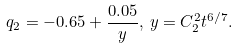<formula> <loc_0><loc_0><loc_500><loc_500>q _ { 2 } = - 0 . 6 5 + \frac { 0 . 0 5 } { y } , \, y = C _ { 2 } ^ { 2 } t ^ { 6 / 7 } .</formula> 